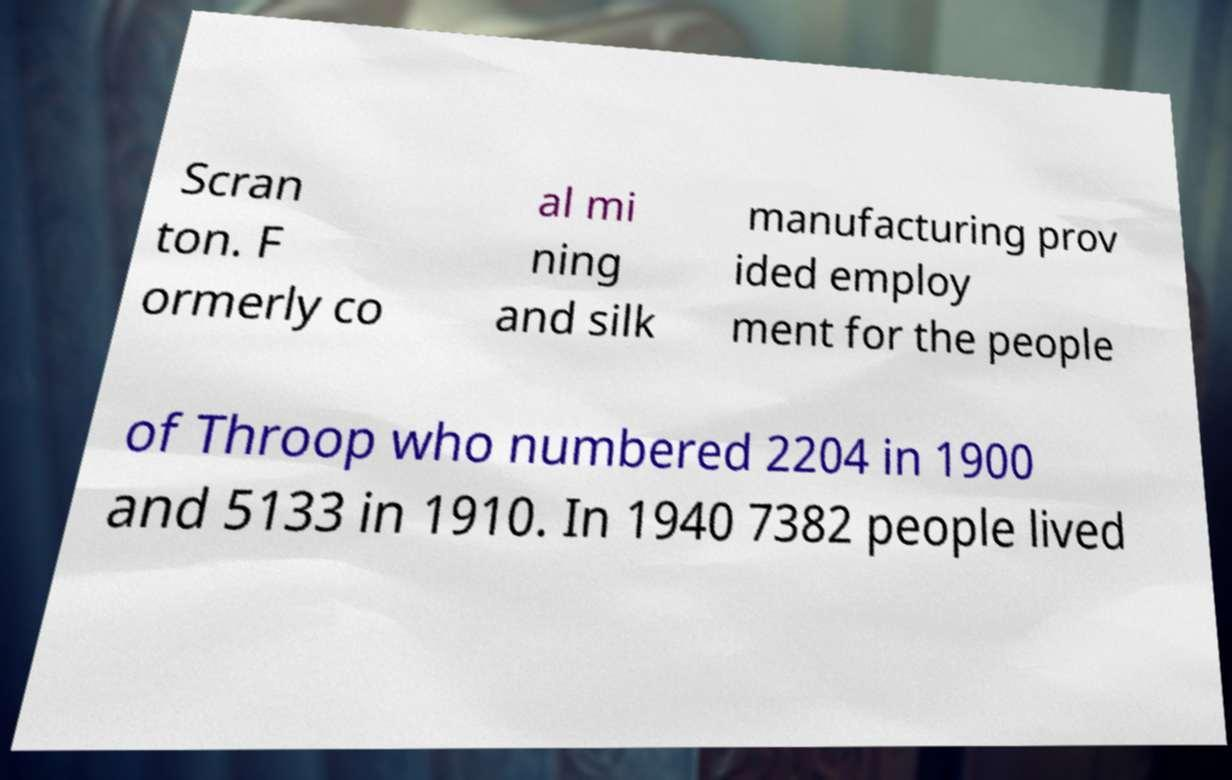Could you extract and type out the text from this image? Scran ton. F ormerly co al mi ning and silk manufacturing prov ided employ ment for the people of Throop who numbered 2204 in 1900 and 5133 in 1910. In 1940 7382 people lived 